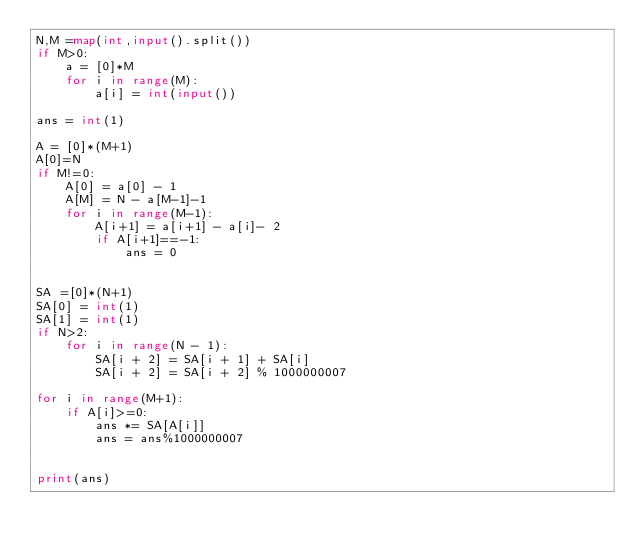<code> <loc_0><loc_0><loc_500><loc_500><_Python_>N,M =map(int,input().split())
if M>0:
    a = [0]*M
    for i in range(M):
        a[i] = int(input())

ans = int(1)

A = [0]*(M+1)
A[0]=N
if M!=0:
    A[0] = a[0] - 1
    A[M] = N - a[M-1]-1
    for i in range(M-1):
        A[i+1] = a[i+1] - a[i]- 2
        if A[i+1]==-1:
            ans = 0


SA =[0]*(N+1)
SA[0] = int(1)
SA[1] = int(1)
if N>2:
    for i in range(N - 1):
        SA[i + 2] = SA[i + 1] + SA[i]
        SA[i + 2] = SA[i + 2] % 1000000007

for i in range(M+1):
    if A[i]>=0:
        ans *= SA[A[i]]
        ans = ans%1000000007


print(ans)
</code> 